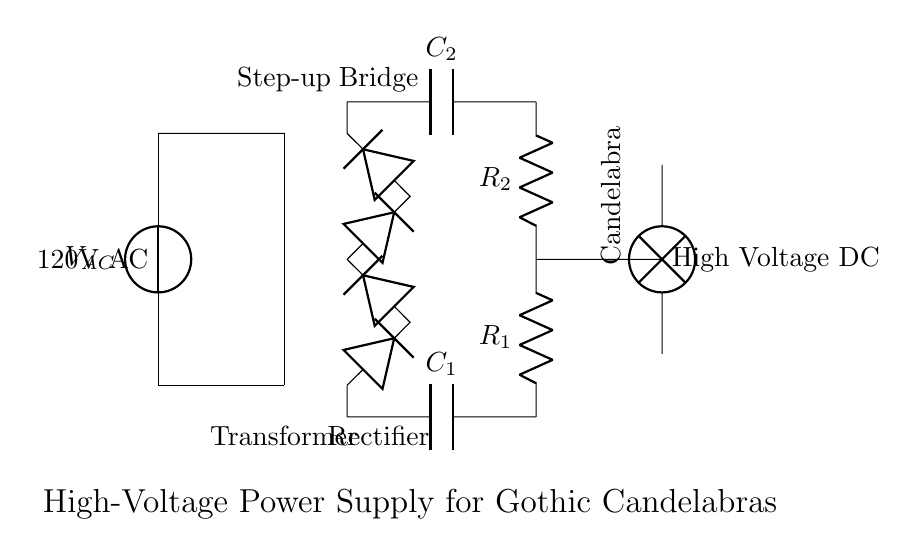What is the input voltage of this circuit? The input voltage is indicated as 120V AC beside the voltage source in the circuit.
Answer: 120V AC What type of transformer is used in this circuit? The circuit employs a step-up transformer, which is labeled as such next to the transformer core.
Answer: Step-up What is the function of the rectifier bridge in this circuit? The rectifier bridge converts alternating current (AC) from the transformer to direct current (DC), allowing for smooth operation of the candelabra.
Answer: Convert AC to DC What are the values of the resistors in the voltage divider? The resistors are labeled as R1 and R2. The actual values are not specified in the diagram; thus, they would need to be determined from additional data or specifications.
Answer: R1 and R2 What is the purpose of the capacitors in this circuit? The capacitors are used for smoothing the output DC voltage from the rectifier, reducing ripple and providing stable voltage to the load, in this case, the candelabra.
Answer: Smoothing Why is a step-up transformer necessary for this application? A step-up transformer increases the input voltage, necessary for powering high-voltage devices like antique candelabras, which require higher voltage levels for efficient operation.
Answer: To increase voltage What type of load does this circuit provide for? The load in this circuit is a lamp, specifically an electric candelabra, as indicated in the diagram.
Answer: Candelabra 